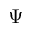<formula> <loc_0><loc_0><loc_500><loc_500>\Psi</formula> 